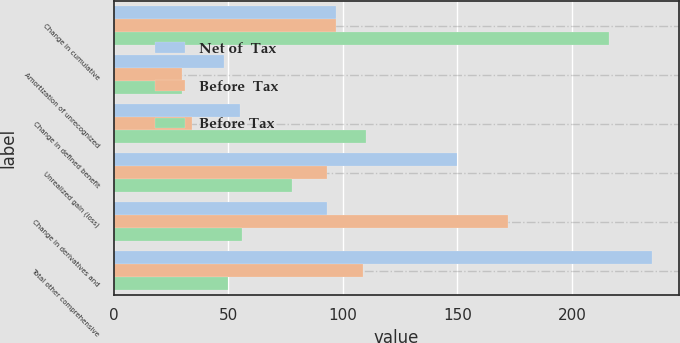<chart> <loc_0><loc_0><loc_500><loc_500><stacked_bar_chart><ecel><fcel>Change in cumulative<fcel>Amortization of unrecognized<fcel>Change in defined benefit<fcel>Unrealized gain (loss)<fcel>Change in derivatives and<fcel>Total other comprehensive<nl><fcel>Net of  Tax<fcel>97<fcel>48<fcel>55<fcel>150<fcel>93<fcel>235<nl><fcel>Before  Tax<fcel>97<fcel>30<fcel>34<fcel>93<fcel>172<fcel>109<nl><fcel>Before Tax<fcel>216<fcel>30<fcel>110<fcel>78<fcel>56<fcel>50<nl></chart> 